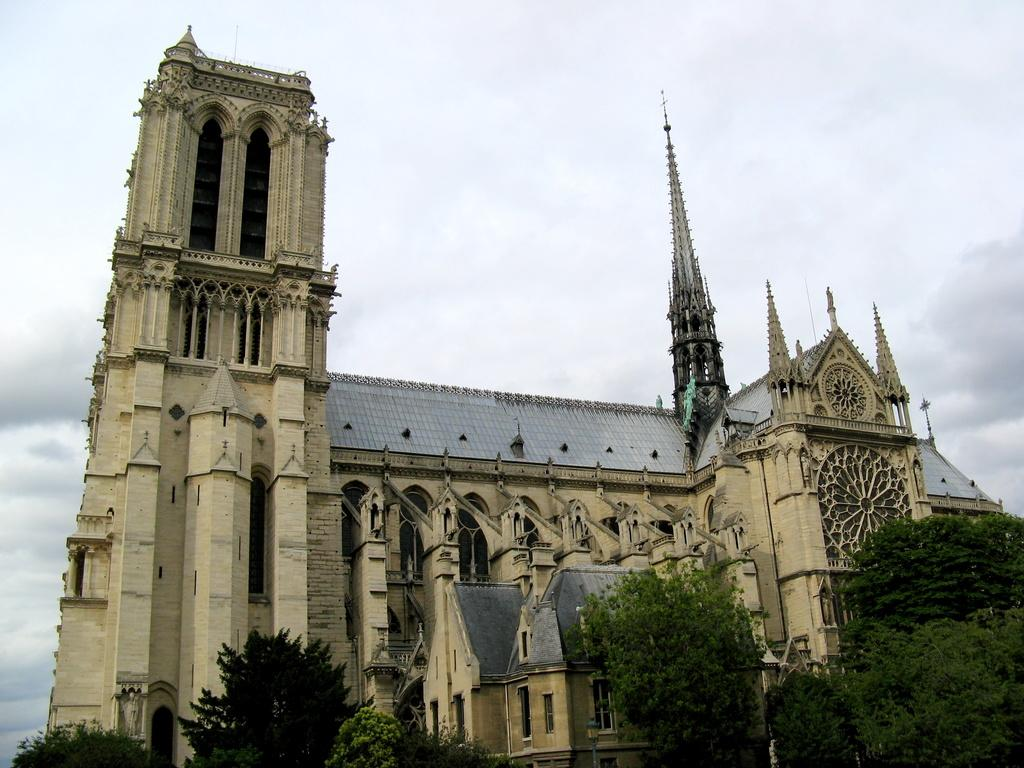What type of vegetation is visible in the image? There are trees in the image. What type of structure can be seen in the image? There is a castle in the image. What is the condition of the sky in the background of the image? The sky is cloudy in the background of the image. What is the price of the whistle in the image? There is no whistle present in the image. What time of day is depicted in the image? The provided facts do not give any information about the time of day in the image. 